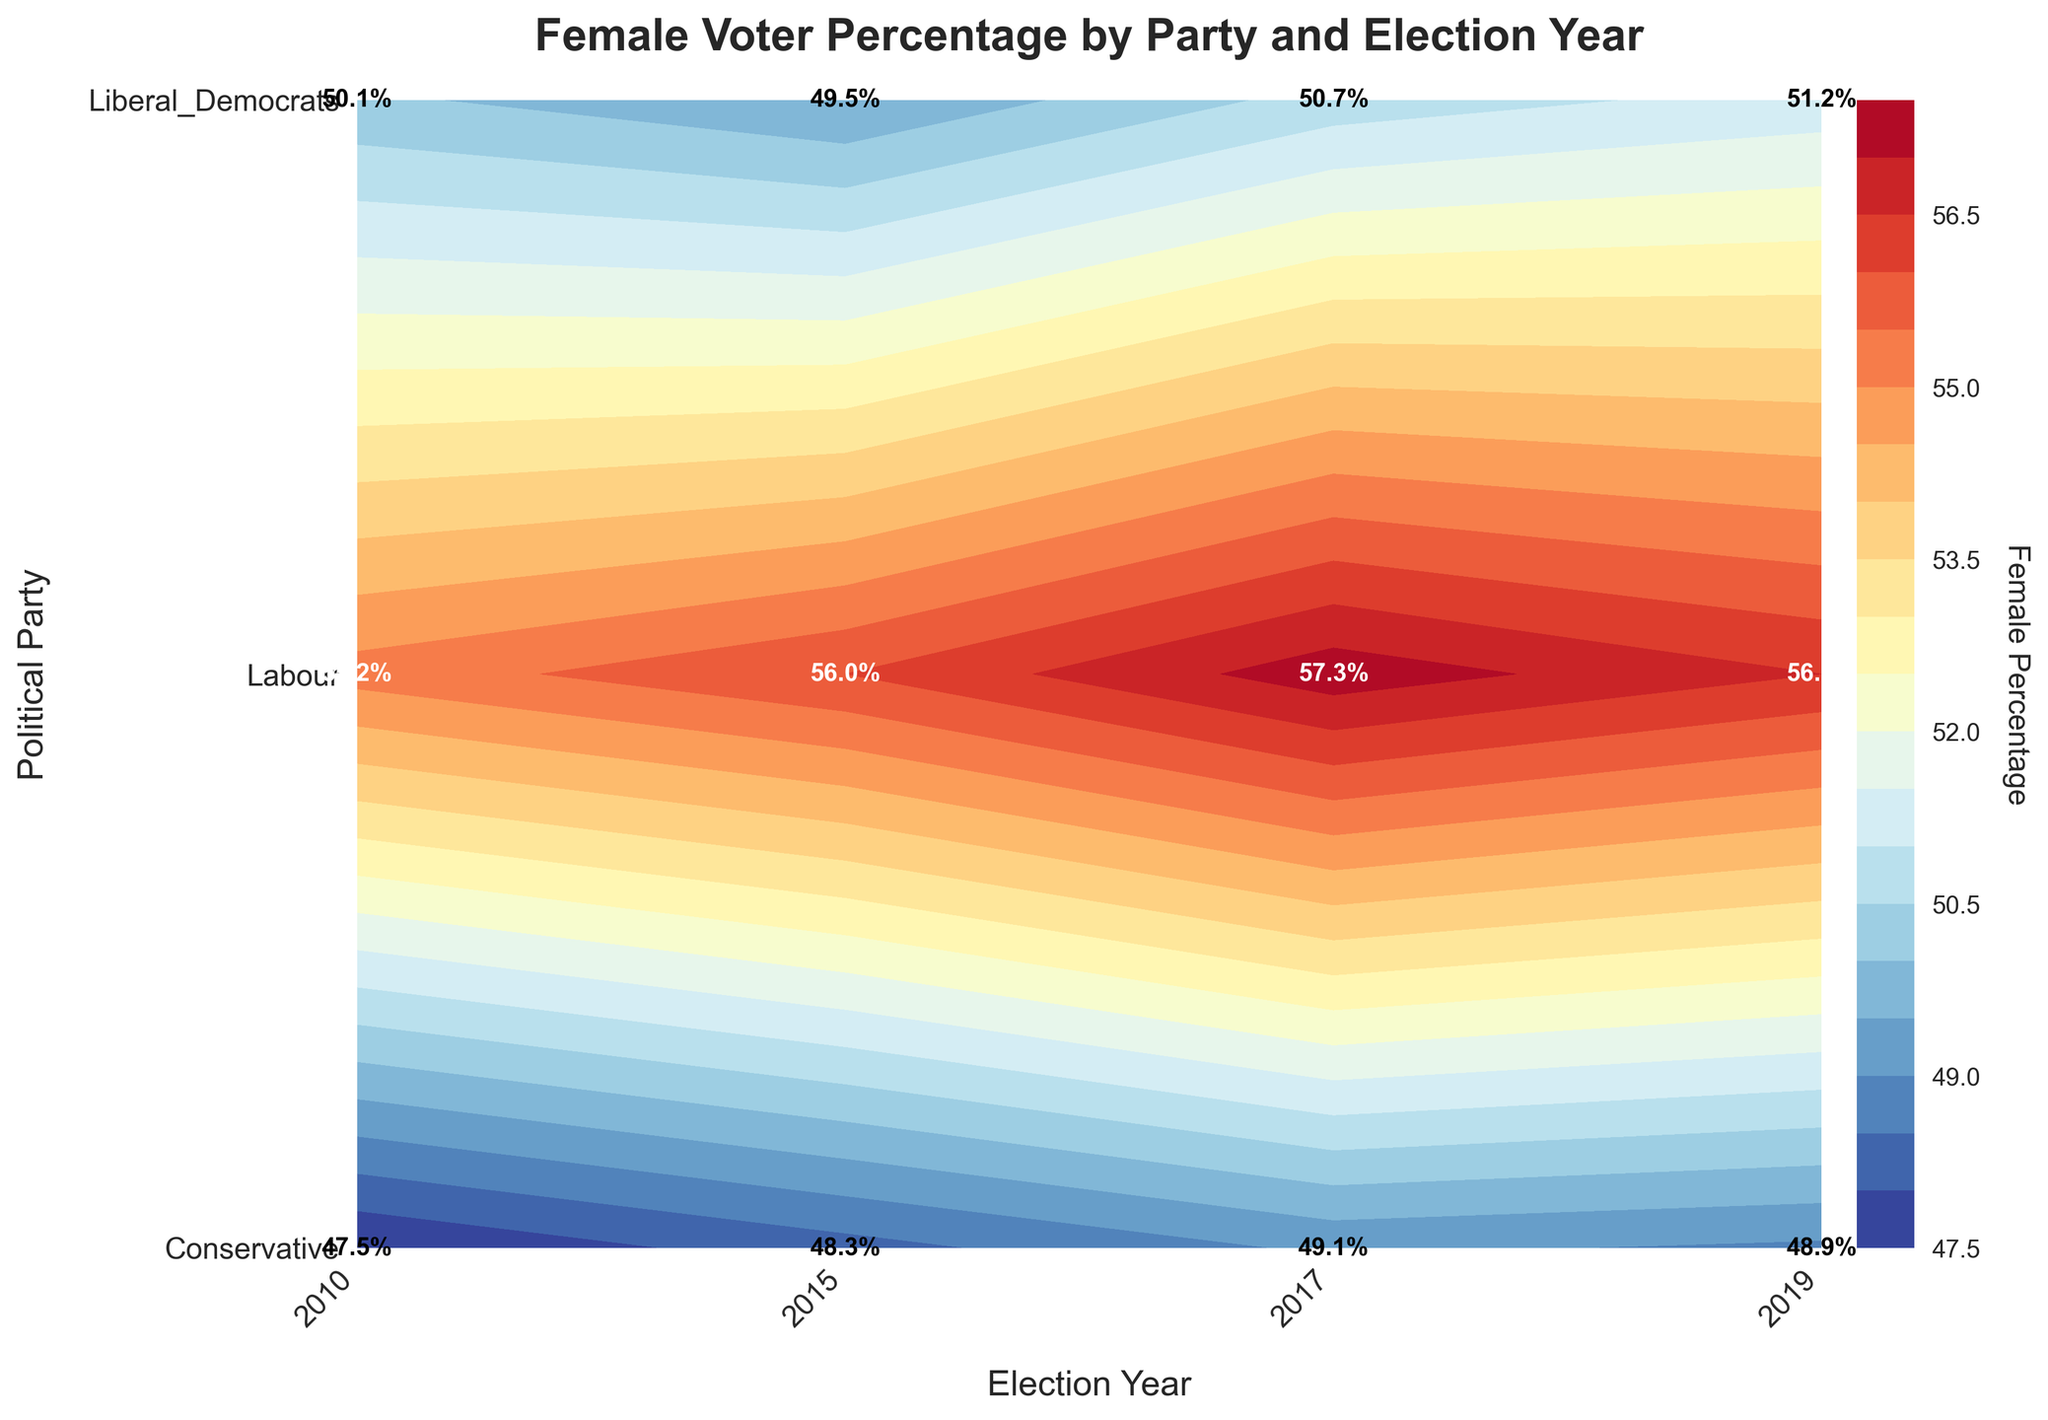What is the title of the plot? The title is displayed at the top of the figure in bold font. It reads "Female Voter Percentage by Party and Election Year".
Answer: Female Voter Percentage by Party and Election Year What parties are represented in the plot? The y-axis labels represent the political parties. They are 'Conservative', 'Labour', and 'Liberal_Democrats'.
Answer: Conservative, Labour, Liberal_Democrats In which election year did the Conservative party have the highest percentage of female voters? Looking at the values annotated within the contour plot, the Conservative party has the highest female percentage in 2017 with 49.1%.
Answer: 2017 What is the female voter percentage for the Labour party in the 2015 election? Locate the Labour party on the y-axis and the 2015 election on the x-axis. The value at the intersection is 56.0%.
Answer: 56.0% How does the female voter percentage trend for the Liberal Democrats from 2010 to 2019? Observe the values for the Liberal Democrats along the x-axis from 2010 to 2019: 50.1%, 49.5%, 50.7%, and 51.2%. The female voter percentage shows a generally increasing trend.
Answer: Increasing trend Which party shows the highest female voter percentage in the 2017 election? Compare the values of all parties in the 2017 column. Labour has the highest value with 57.3%.
Answer: Labour What is the average female voter percentage for the Conservative party across all election years? Sum the percentages for Conservative (47.5 + 48.3 + 49.1 + 48.9) and divide by 4. (47.5 + 48.3 + 49.1 + 48.9) / 4 = 48.5%.
Answer: 48.5% Is there any year in which all three parties had a female voter percentage below 50%? Check the values for all three parties for each year. In 2015, both Conservative and Liberal Democrats have percentages below 50%, but Labour does not. No year meets this criterion.
Answer: No Which party and year combination has the lowest female voter percentage on the plot? Compare all values on the contour plot. The lowest value is for Conservative in 2010 with 47.5%.
Answer: Conservative, 2010 Does the contour plot indicate a broader gender balance trend among voters across parties and elections? Reviewing the color gradient and annotations, Labour consistently has the higher female percentages, whereas Conservative and Liberal Democrats have more balanced distributions around 50%. Labour tends to attract more female voters across all years.
Answer: Labour attracts more female voters 